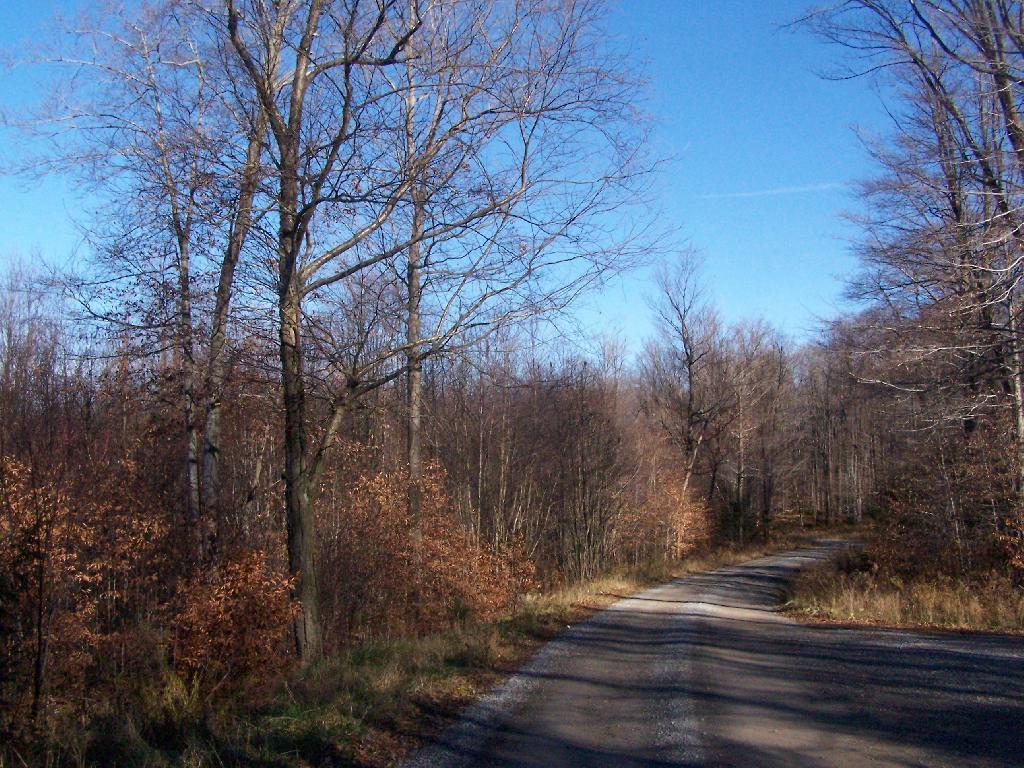What is the main feature of the image? There is a road in the image. What can be seen on either side of the road? There are plants and trees on either side of the road. What is visible in the background of the image? The sky is visible in the background of the image. What is the price of the wind in the image? There is no wind present in the image, and therefore no price can be determined. 